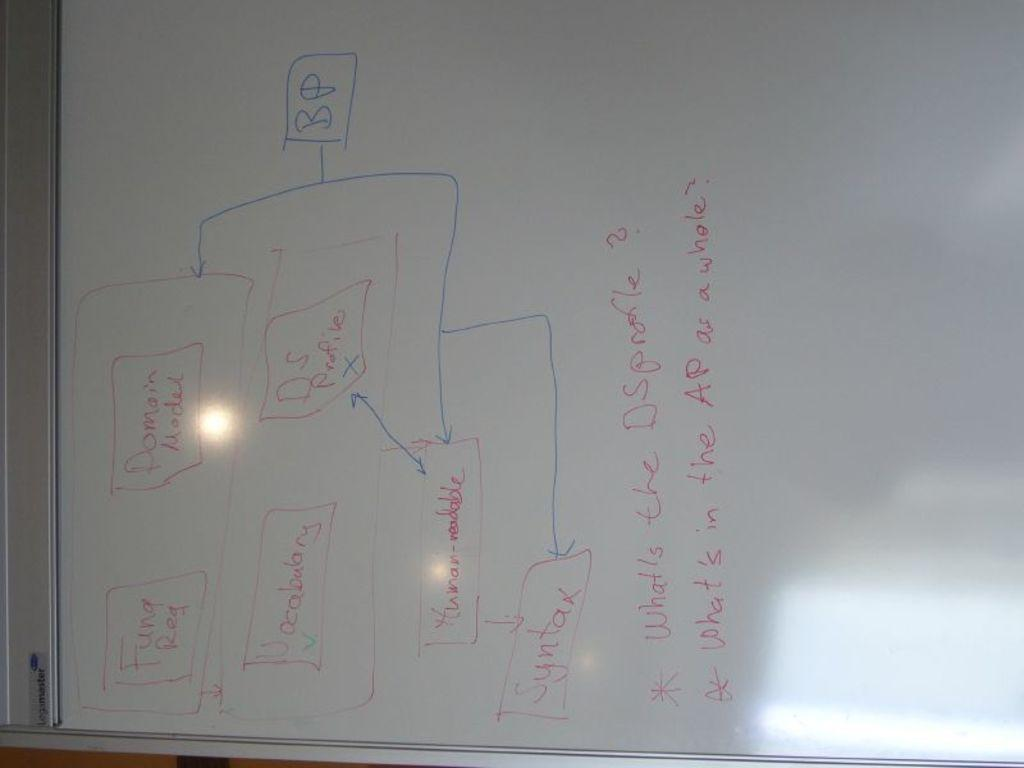<image>
Relay a brief, clear account of the picture shown. Whiteboard detailing Fund Req, Domain Model, Vocabulary, Syntax for AP analysis. 